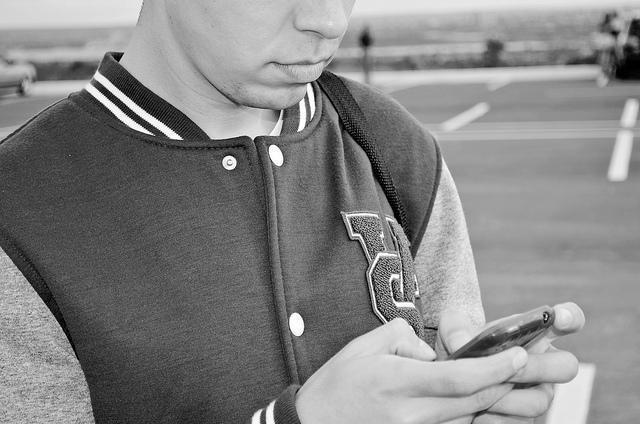How many laptops are there?
Give a very brief answer. 0. 